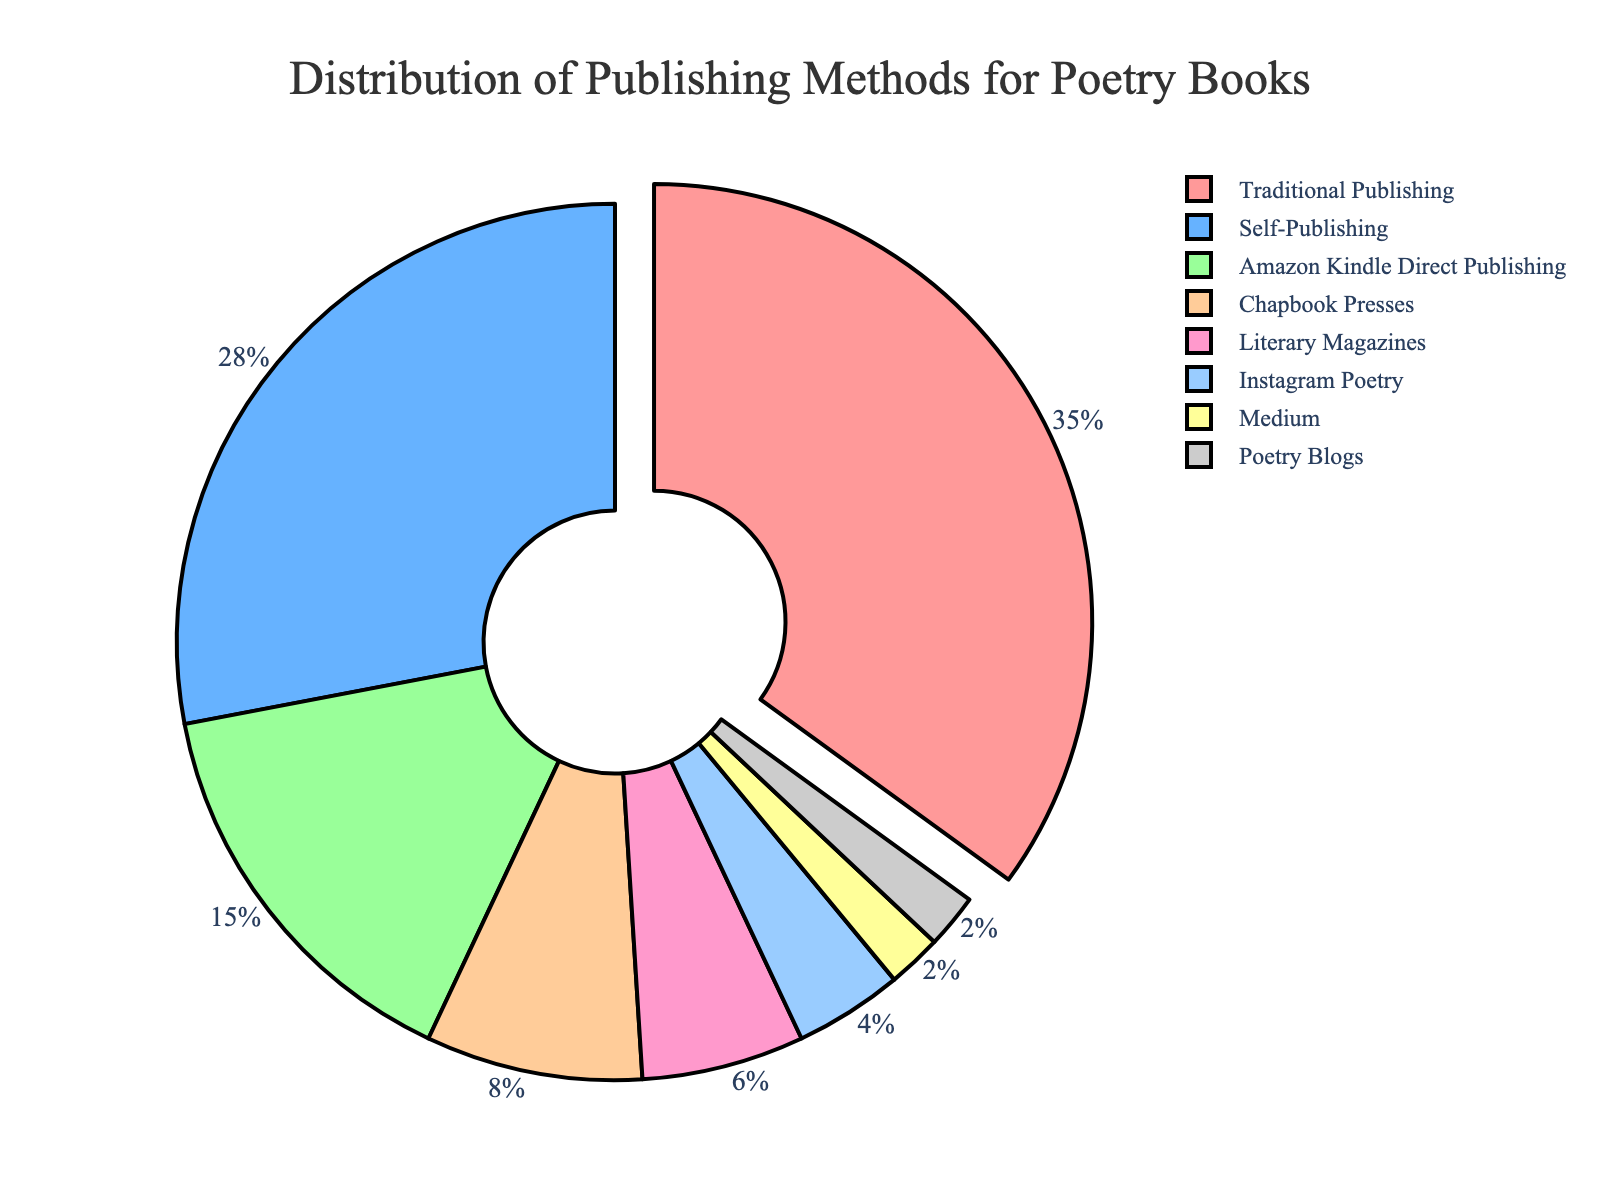What's the main publishing method for poetry books? The pie chart shows that the largest portion of the chart, 35%, is dedicated to Traditional Publishing. This indicates it is the main method.
Answer: Traditional Publishing What's the combined percentage of traditional and self-publishing methods? Traditional Publishing is 35% and Self-Publishing is 28%. Adding these two percentages together results in 35% + 28% = 63%.
Answer: 63% Which online platform has the highest percentage for publishing poetry books? From the visual inspection, Amazon Kindle Direct Publishing has the highest percentage among online platforms, which is 15%.
Answer: Amazon Kindle Direct Publishing Is the percentage of Chapbook Presses higher than Literary Magazines? The pie chart shows that Chapbook Presses account for 8% whereas Literary Magazines account for 6%, making Chapbook Presses higher.
Answer: Yes What is the difference in percentage between Instagram Poetry and Poetry Blogs? Instagram Poetry accounts for 4% and Poetry Blogs account for 2%. The difference would be 4% - 2% = 2%.
Answer: 2% What's the smallest segment in the pie chart? The pie chart shows the smallest segments are Medium and Poetry Blogs, both accounting for 2% each.
Answer: Medium and Poetry Blogs Which method appears second-most popular after Traditional Publishing? The pie chart indicates Self-Publishing has the second-largest percentage at 28%.
Answer: Self-Publishing How do online platforms (Amazon Kindle, Instagram Poetry, Medium, Poetry Blogs) collectively compare to Traditional Publishing in terms of percentage? The combined percentage for Amazon Kindle Direct Publishing (15%), Instagram Poetry (4%), Medium (2%), and Poetry Blogs (2%) is 15% + 4% + 2% + 2% = 23%. Traditional Publishing alone is 35%. So, Traditional Publishing is higher by 35% - 23% = 12%.
Answer: Traditional Publishing is higher by 12% What is the total percentage for the least popular methods combined (those below 10%)? Adding the percentages for Chapbook Presses (8%), Literary Magazines (6%), Instagram Poetry (4%), Medium (2%), and Poetry Blogs (2%) results in 8% + 6% + 4% + 2% + 2% = 22%.
Answer: 22% 